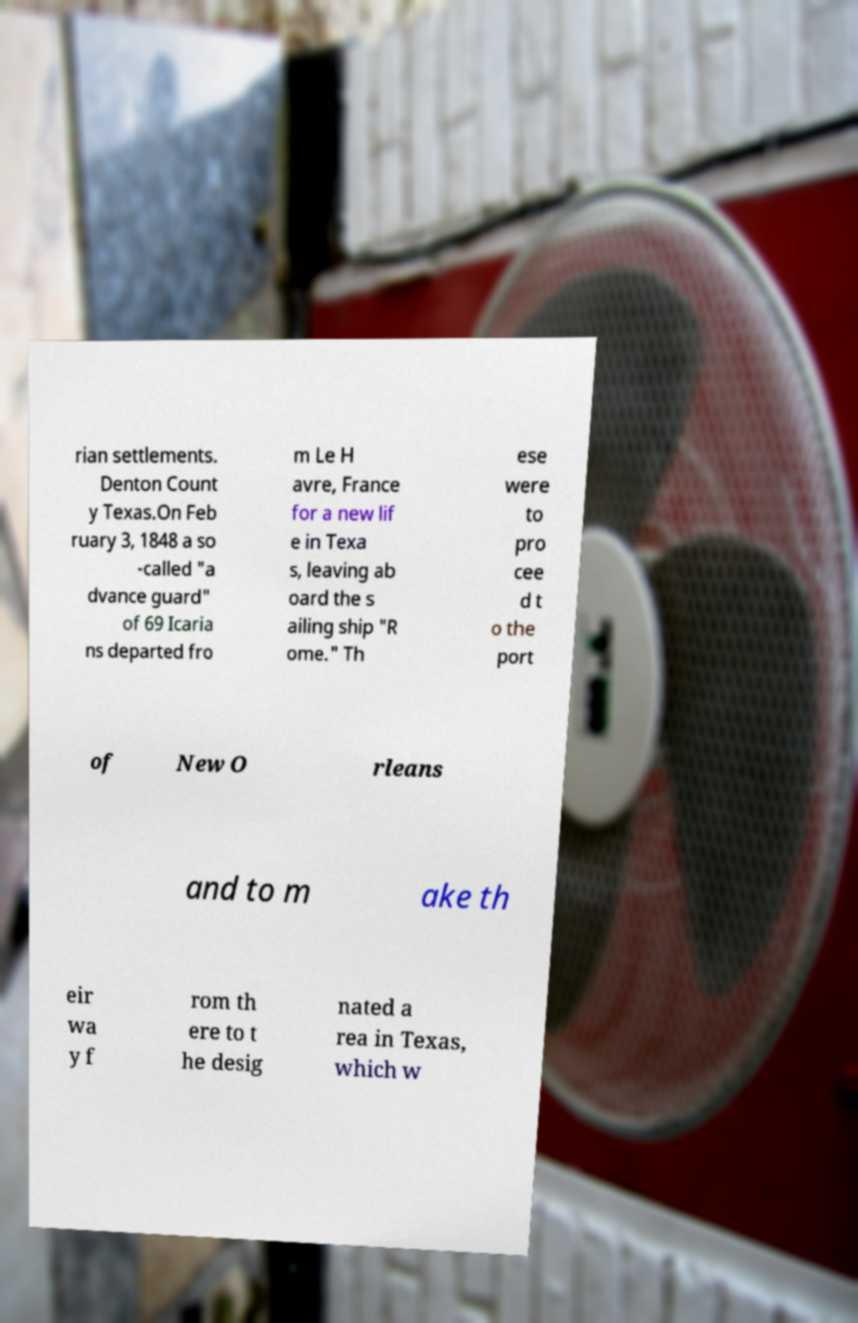What messages or text are displayed in this image? I need them in a readable, typed format. rian settlements. Denton Count y Texas.On Feb ruary 3, 1848 a so -called "a dvance guard" of 69 Icaria ns departed fro m Le H avre, France for a new lif e in Texa s, leaving ab oard the s ailing ship "R ome." Th ese were to pro cee d t o the port of New O rleans and to m ake th eir wa y f rom th ere to t he desig nated a rea in Texas, which w 